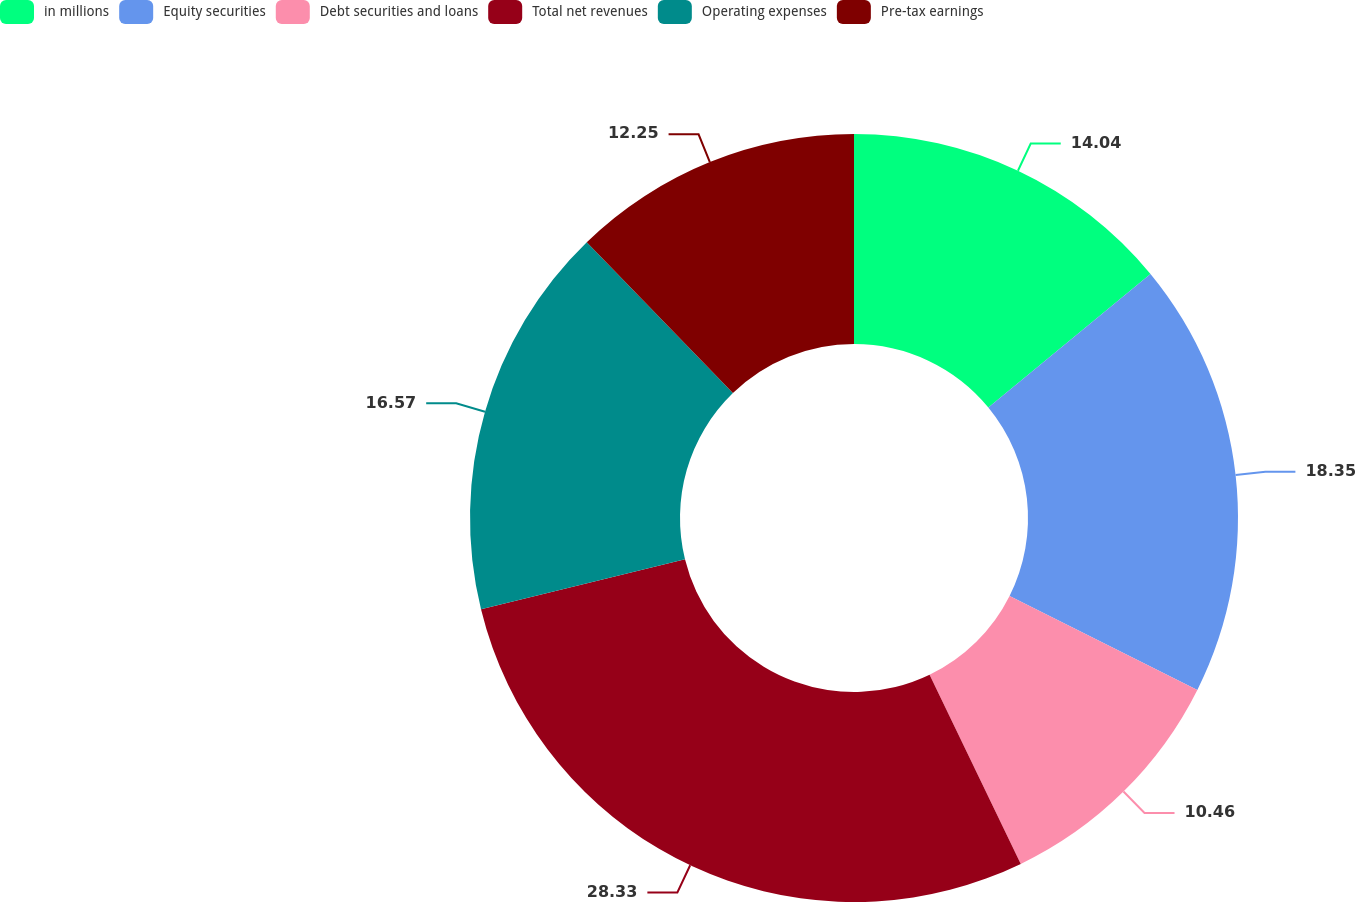Convert chart to OTSL. <chart><loc_0><loc_0><loc_500><loc_500><pie_chart><fcel>in millions<fcel>Equity securities<fcel>Debt securities and loans<fcel>Total net revenues<fcel>Operating expenses<fcel>Pre-tax earnings<nl><fcel>14.04%<fcel>18.35%<fcel>10.46%<fcel>28.33%<fcel>16.57%<fcel>12.25%<nl></chart> 